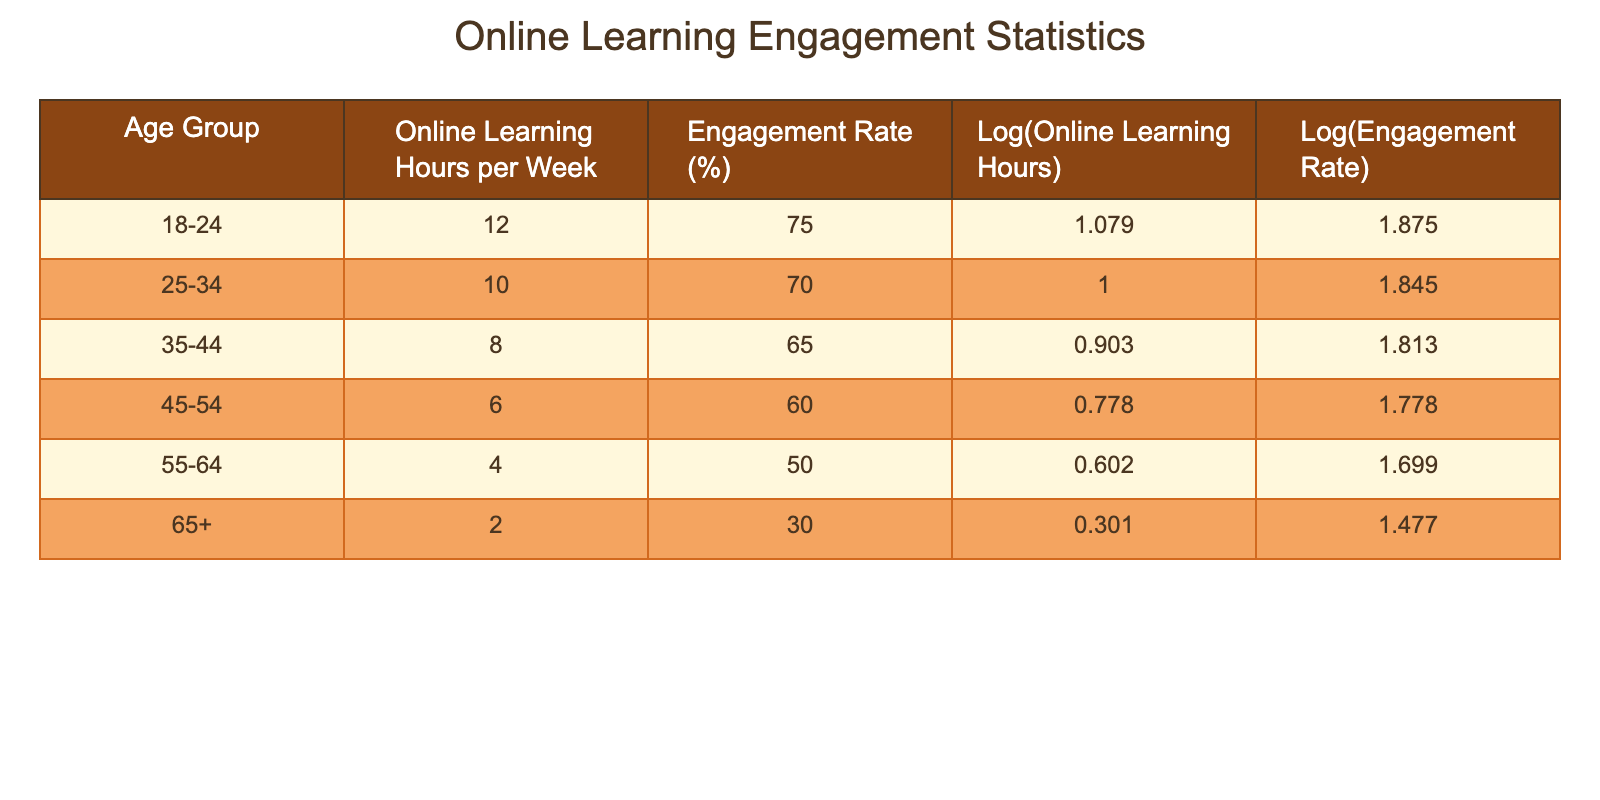What is the engagement rate for the age group 25-34? Referring to the table, the engagement rate for the age group 25-34 is listed directly under that age group.
Answer: 70% What are the online learning hours per week for the age group 55-64? The value for online learning hours per week for the age group 55-64 can be found directly in the corresponding row.
Answer: 4 Is the engagement rate for the age group 45-54 greater than the engagement rate for the age group 35-44? The engagement rate for 45-54 is 60%, and for 35-44 it is 65%. Since 60% is less than 65%, the statement is false.
Answer: No What is the average number of online learning hours per week across all age groups? We add the online learning hours: 12 + 10 + 8 + 6 + 4 + 2 = 42. There are 6 age groups, so we divide: 42/6 = 7.
Answer: 7 Are there any age groups with an engagement rate of 75% or higher? The only engagement rate of 75% belongs to the age group 18-24. Therefore, there is one group with this engagement rate.
Answer: Yes What is the difference in online learning hours per week between the age groups 18-24 and 65+? The online learning hours for 18-24 is 12, and for 65+ is 2. The difference is calculated as 12 - 2 = 10.
Answer: 10 What is the logarithmic value of the engagement rate for the age group 55-64? Looking at the table, the logarithmic value of engagement rate for 55-64 is provided as 1.699.
Answer: 1.699 Which age group has the lowest online learning hours per week? By examining the table, we can see that the age group 65+ has the lowest value listed for online learning hours at 2.
Answer: 65+ What is the trend in engagement rates as the age increases from 18-24 to 65+? By reviewing the engagement rates from the table, we observe that they decrease from 75% at 18-24 down to 30% at 65+. This establishes a downward trend in engagement rates with increasing age.
Answer: Decrease 